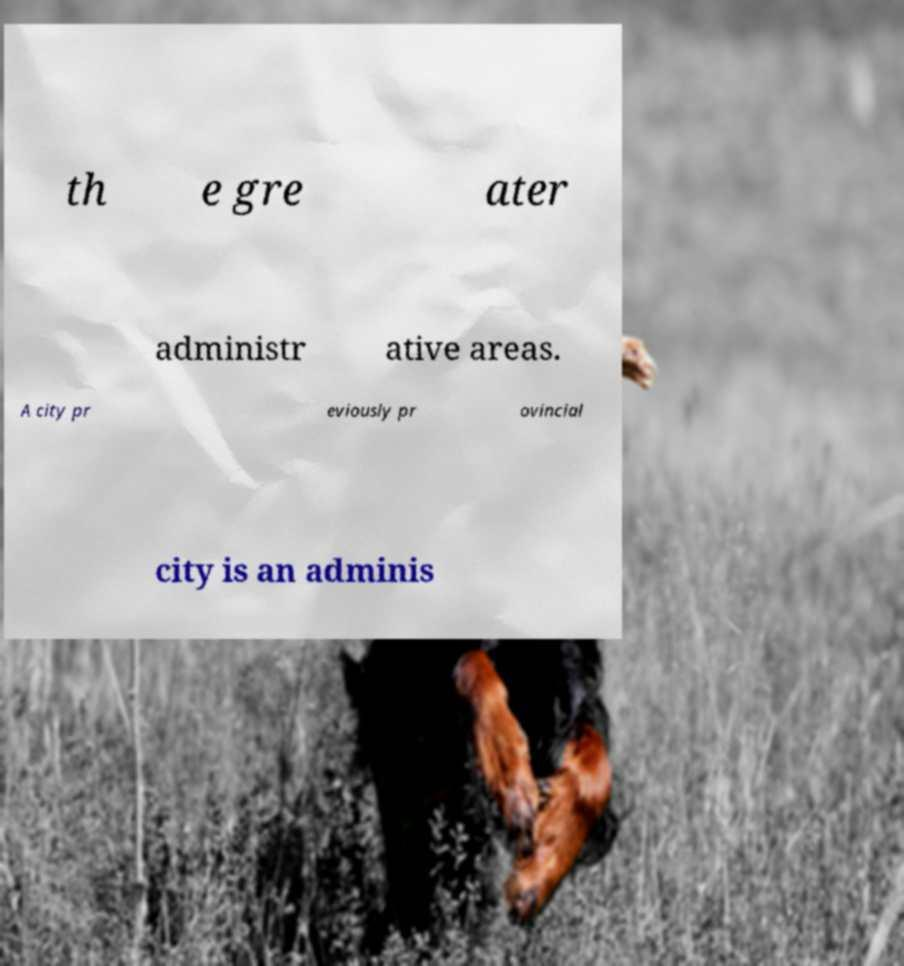What messages or text are displayed in this image? I need them in a readable, typed format. th e gre ater administr ative areas. A city pr eviously pr ovincial city is an adminis 